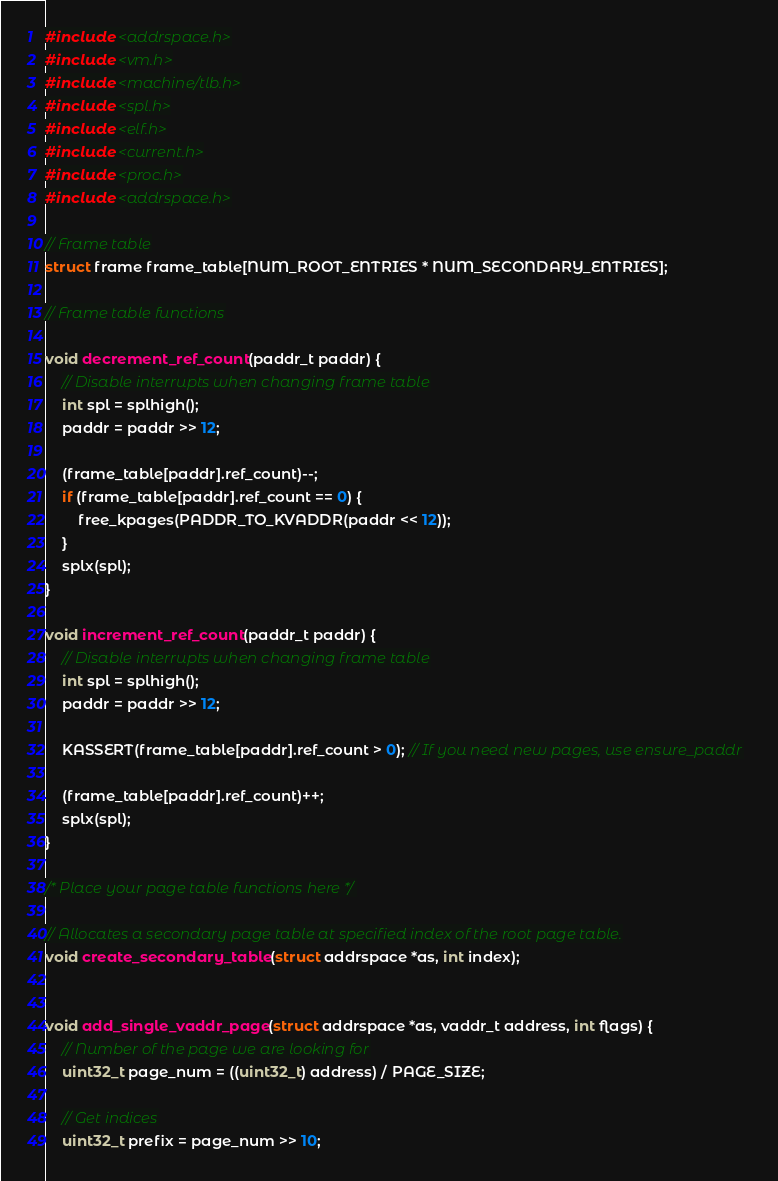<code> <loc_0><loc_0><loc_500><loc_500><_C_>#include <addrspace.h>
#include <vm.h>
#include <machine/tlb.h>
#include <spl.h>
#include <elf.h>
#include <current.h>
#include <proc.h>
#include <addrspace.h>

// Frame table
struct frame frame_table[NUM_ROOT_ENTRIES * NUM_SECONDARY_ENTRIES];

// Frame table functions

void decrement_ref_count(paddr_t paddr) {
    // Disable interrupts when changing frame table
    int spl = splhigh();
    paddr = paddr >> 12;

    (frame_table[paddr].ref_count)--;
    if (frame_table[paddr].ref_count == 0) {
        free_kpages(PADDR_TO_KVADDR(paddr << 12));
    }
    splx(spl);
}

void increment_ref_count(paddr_t paddr) {
    // Disable interrupts when changing frame table
    int spl = splhigh();
    paddr = paddr >> 12;

    KASSERT(frame_table[paddr].ref_count > 0); // If you need new pages, use ensure_paddr

    (frame_table[paddr].ref_count)++;
    splx(spl);
}

/* Place your page table functions here */

// Allocates a secondary page table at specified index of the root page table.
void create_secondary_table(struct addrspace *as, int index);


void add_single_vaddr_page(struct addrspace *as, vaddr_t address, int flags) {
    // Number of the page we are looking for
    uint32_t page_num = ((uint32_t) address) / PAGE_SIZE;

    // Get indices
    uint32_t prefix = page_num >> 10;</code> 